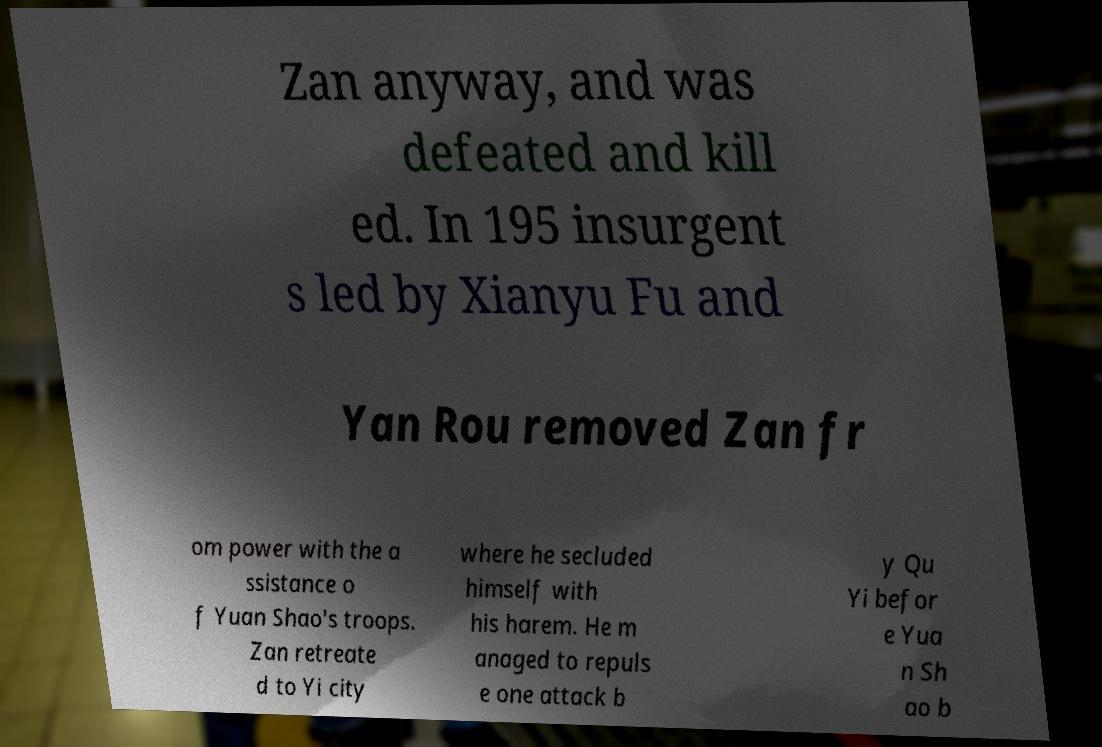Can you accurately transcribe the text from the provided image for me? Zan anyway, and was defeated and kill ed. In 195 insurgent s led by Xianyu Fu and Yan Rou removed Zan fr om power with the a ssistance o f Yuan Shao's troops. Zan retreate d to Yi city where he secluded himself with his harem. He m anaged to repuls e one attack b y Qu Yi befor e Yua n Sh ao b 